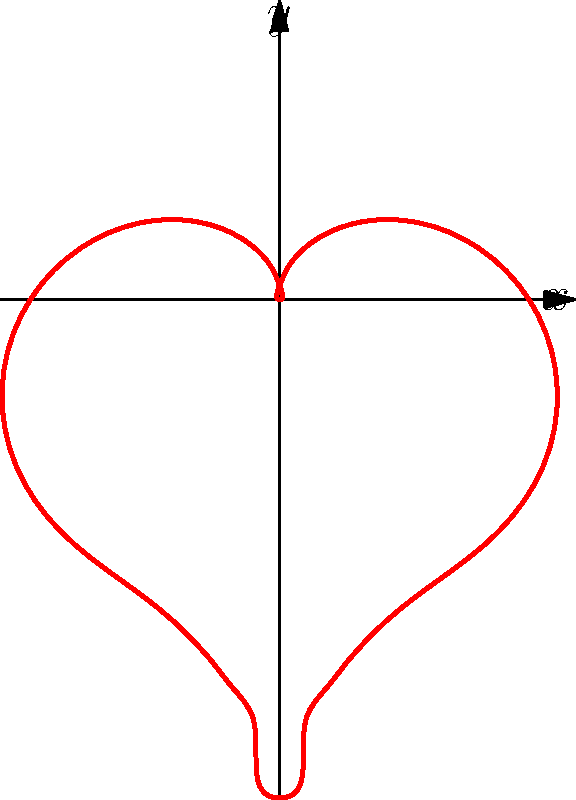Omo! Check out this heart-shaped curve in polar coordinates. If the equation is $r = 2 - 2\sin(\theta) + \frac{\sin(\theta)\sqrt{|\cos(\theta)|}}{(\sin(\theta)+1.4)}$, what's the maximum value of $r$ when $\theta = \frac{\pi}{2}$? Let's break it down step by step, fam:

1) We're looking at $\theta = \frac{\pi}{2}$, which is 90 degrees. This is the top point of the heart.

2) Let's substitute $\theta = \frac{\pi}{2}$ into our equation:

   $r = 2 - 2\sin(\frac{\pi}{2}) + \frac{\sin(\frac{\pi}{2})\sqrt{|\cos(\frac{\pi}{2})|}}{(\sin(\frac{\pi}{2})+1.4)}$

3) Now, let's evaluate:
   - $\sin(\frac{\pi}{2}) = 1$
   - $\cos(\frac{\pi}{2}) = 0$

4) Substituting these values:

   $r = 2 - 2(1) + \frac{1\sqrt{|0|}}{(1+1.4)}$

5) Simplify:
   $r = 2 - 2 + \frac{0}{2.4} = 0$

6) Therefore, at $\theta = \frac{\pi}{2}$, $r = 0$, which is the maximum value at this point (the top of the heart).

No cap, that's how we solve it!
Answer: 0 